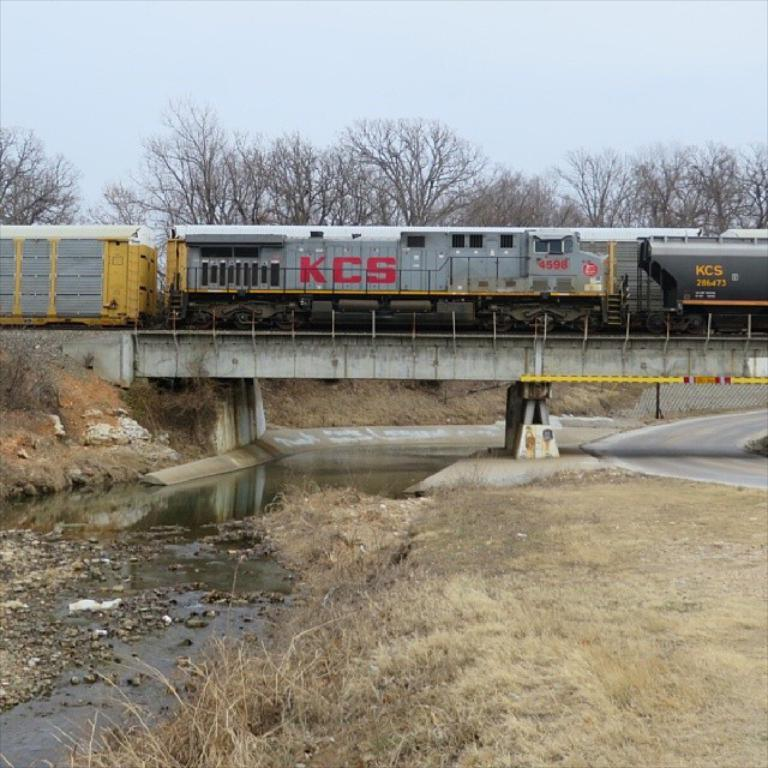What is the main subject of the image? The main subject of the image is a train on a track. Can you describe the location of the track? The track is on a bridge. What can be seen in the left corner of the image? There is water in the left corner of the image. What is visible in the background of the image? There are trees in the background of the image. What type of tin can be seen in the image? There is no tin present in the image. Is the moon visible in the image? The moon is not visible in the image; only the sunlit sky and trees are present. 